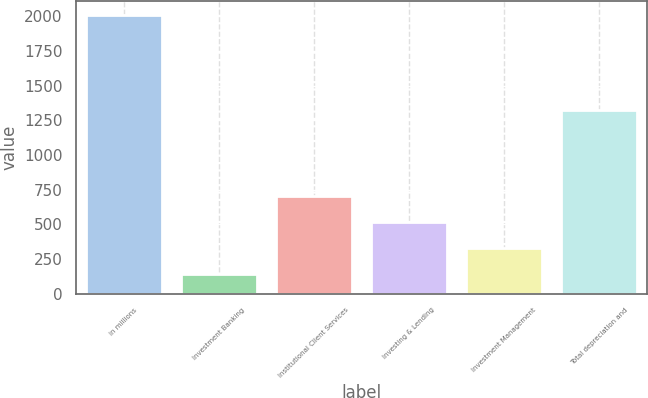Convert chart. <chart><loc_0><loc_0><loc_500><loc_500><bar_chart><fcel>in millions<fcel>Investment Banking<fcel>Institutional Client Services<fcel>Investing & Lending<fcel>Investment Management<fcel>Total depreciation and<nl><fcel>2013<fcel>143<fcel>704<fcel>517<fcel>330<fcel>1322<nl></chart> 